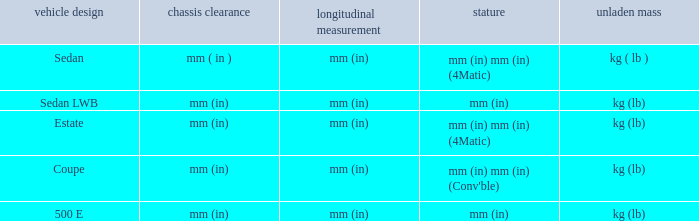What are the lengths of the models that are mm (in) tall? Mm (in), mm (in). 